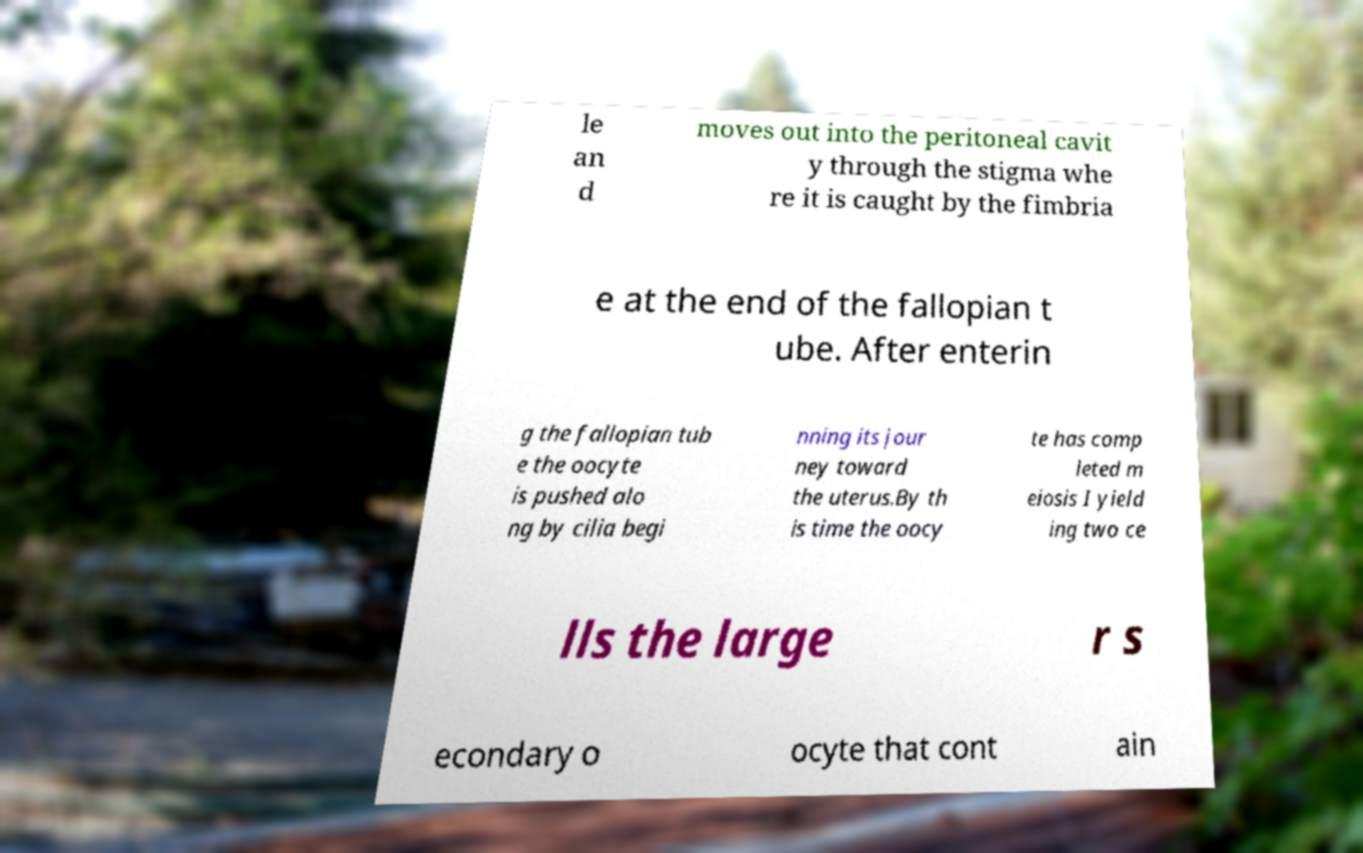For documentation purposes, I need the text within this image transcribed. Could you provide that? le an d moves out into the peritoneal cavit y through the stigma whe re it is caught by the fimbria e at the end of the fallopian t ube. After enterin g the fallopian tub e the oocyte is pushed alo ng by cilia begi nning its jour ney toward the uterus.By th is time the oocy te has comp leted m eiosis I yield ing two ce lls the large r s econdary o ocyte that cont ain 